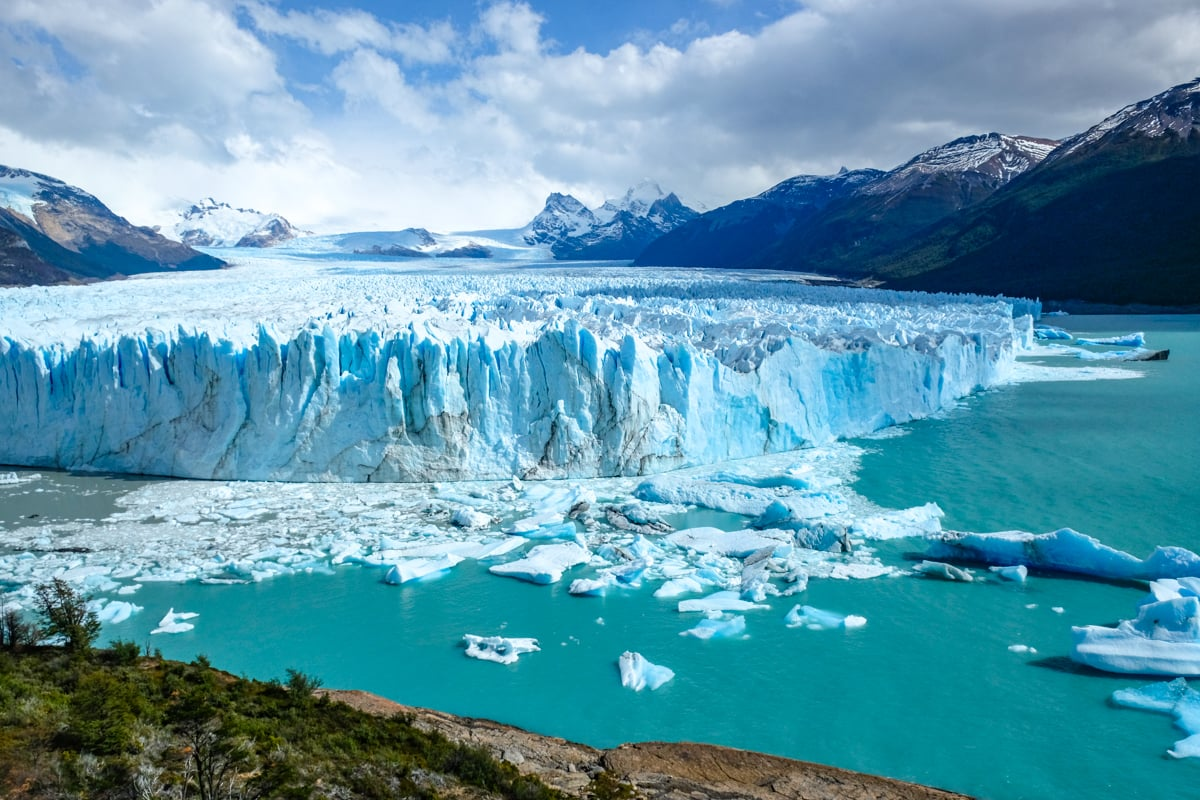Analyze the image in a comprehensive and detailed manner.
 The image captures the breathtaking view of the Perito Moreno Glacier, located in El Calafate, Argentina. The glacier, with its bright blue hue, stands as a magnificent spectacle amidst the surrounding landscape. From a high vantage point, the perspective of the photo offers a panoramic view of the glacier, the turquoise water, and the snow-capped mountains in the background. Small icebergs, fragments from the glacier, can be seen floating in the water, adding to the surreal beauty of the scene. The sky above is a canvas of bright blue, dotted with a few clouds, completing this picturesque view of one of nature's most awe-inspiring landmarks. 